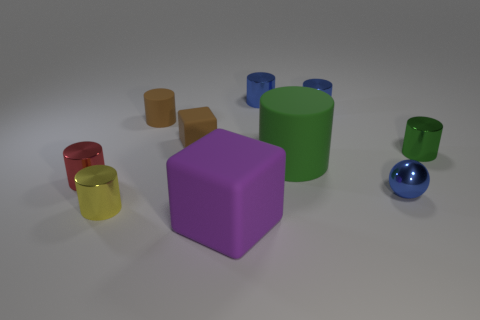What colors can be seen on the objects in this image, and which shape is most frequent? The colors visible on the objects include red, yellow, green, blue, brown, and purple. The most frequent shape is the cylinder, with various sizes represented. Which object stands out the most to you, and why? The large purple cube stands out the most due to its central position, solid color, and size contrast compared to the surrounding objects. 